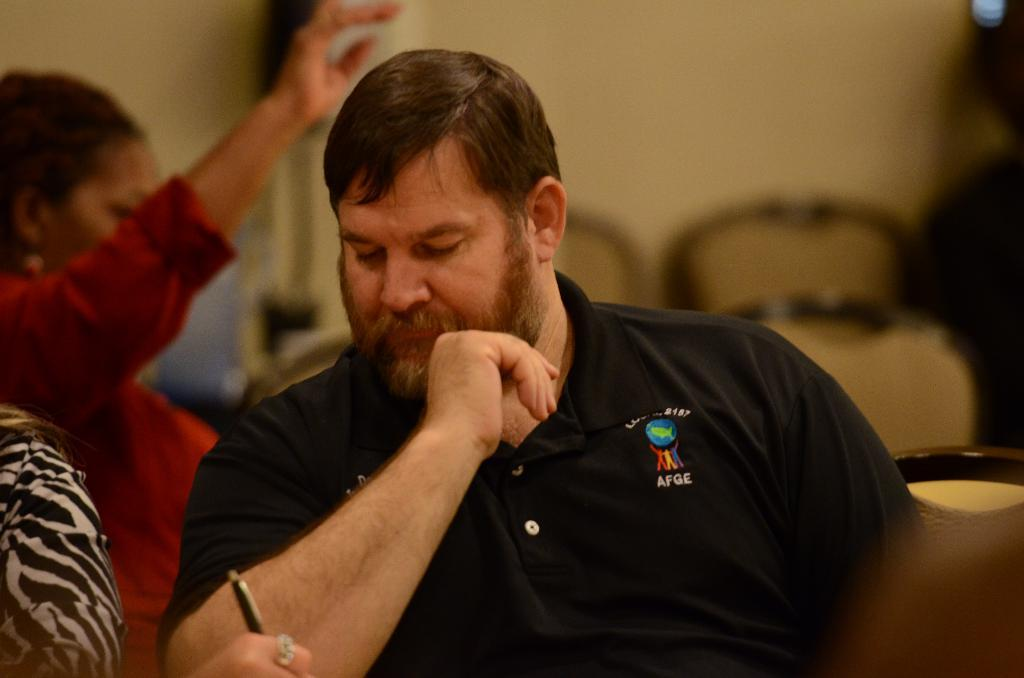What is the man in the image wearing? The man is wearing a black T-shirt. What is the woman in the image wearing? The woman is wearing a red dress. What are the man and woman doing in the image? Both the man and woman are sitting on chairs. What can be seen in the background of the image? There are chairs and a wall in the background of the image. How many snails can be seen crawling on the wall in the image? There are no snails visible in the image; the wall is clear of any snails. 